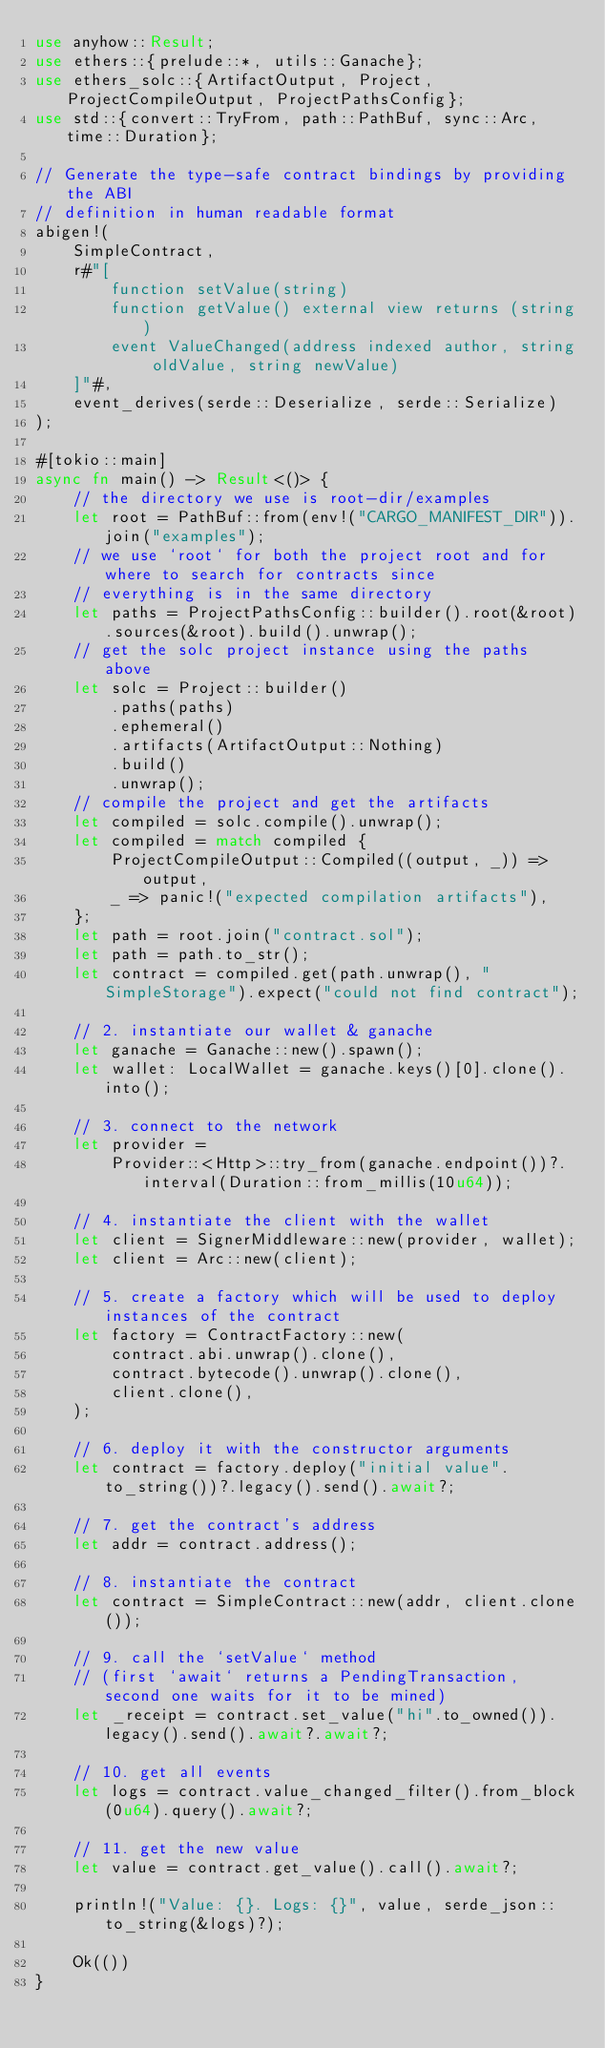Convert code to text. <code><loc_0><loc_0><loc_500><loc_500><_Rust_>use anyhow::Result;
use ethers::{prelude::*, utils::Ganache};
use ethers_solc::{ArtifactOutput, Project, ProjectCompileOutput, ProjectPathsConfig};
use std::{convert::TryFrom, path::PathBuf, sync::Arc, time::Duration};

// Generate the type-safe contract bindings by providing the ABI
// definition in human readable format
abigen!(
    SimpleContract,
    r#"[
        function setValue(string)
        function getValue() external view returns (string)
        event ValueChanged(address indexed author, string oldValue, string newValue)
    ]"#,
    event_derives(serde::Deserialize, serde::Serialize)
);

#[tokio::main]
async fn main() -> Result<()> {
    // the directory we use is root-dir/examples
    let root = PathBuf::from(env!("CARGO_MANIFEST_DIR")).join("examples");
    // we use `root` for both the project root and for where to search for contracts since
    // everything is in the same directory
    let paths = ProjectPathsConfig::builder().root(&root).sources(&root).build().unwrap();
    // get the solc project instance using the paths above
    let solc = Project::builder()
        .paths(paths)
        .ephemeral()
        .artifacts(ArtifactOutput::Nothing)
        .build()
        .unwrap();
    // compile the project and get the artifacts
    let compiled = solc.compile().unwrap();
    let compiled = match compiled {
        ProjectCompileOutput::Compiled((output, _)) => output,
        _ => panic!("expected compilation artifacts"),
    };
    let path = root.join("contract.sol");
    let path = path.to_str();
    let contract = compiled.get(path.unwrap(), "SimpleStorage").expect("could not find contract");

    // 2. instantiate our wallet & ganache
    let ganache = Ganache::new().spawn();
    let wallet: LocalWallet = ganache.keys()[0].clone().into();

    // 3. connect to the network
    let provider =
        Provider::<Http>::try_from(ganache.endpoint())?.interval(Duration::from_millis(10u64));

    // 4. instantiate the client with the wallet
    let client = SignerMiddleware::new(provider, wallet);
    let client = Arc::new(client);

    // 5. create a factory which will be used to deploy instances of the contract
    let factory = ContractFactory::new(
        contract.abi.unwrap().clone(),
        contract.bytecode().unwrap().clone(),
        client.clone(),
    );

    // 6. deploy it with the constructor arguments
    let contract = factory.deploy("initial value".to_string())?.legacy().send().await?;

    // 7. get the contract's address
    let addr = contract.address();

    // 8. instantiate the contract
    let contract = SimpleContract::new(addr, client.clone());

    // 9. call the `setValue` method
    // (first `await` returns a PendingTransaction, second one waits for it to be mined)
    let _receipt = contract.set_value("hi".to_owned()).legacy().send().await?.await?;

    // 10. get all events
    let logs = contract.value_changed_filter().from_block(0u64).query().await?;

    // 11. get the new value
    let value = contract.get_value().call().await?;

    println!("Value: {}. Logs: {}", value, serde_json::to_string(&logs)?);

    Ok(())
}
</code> 